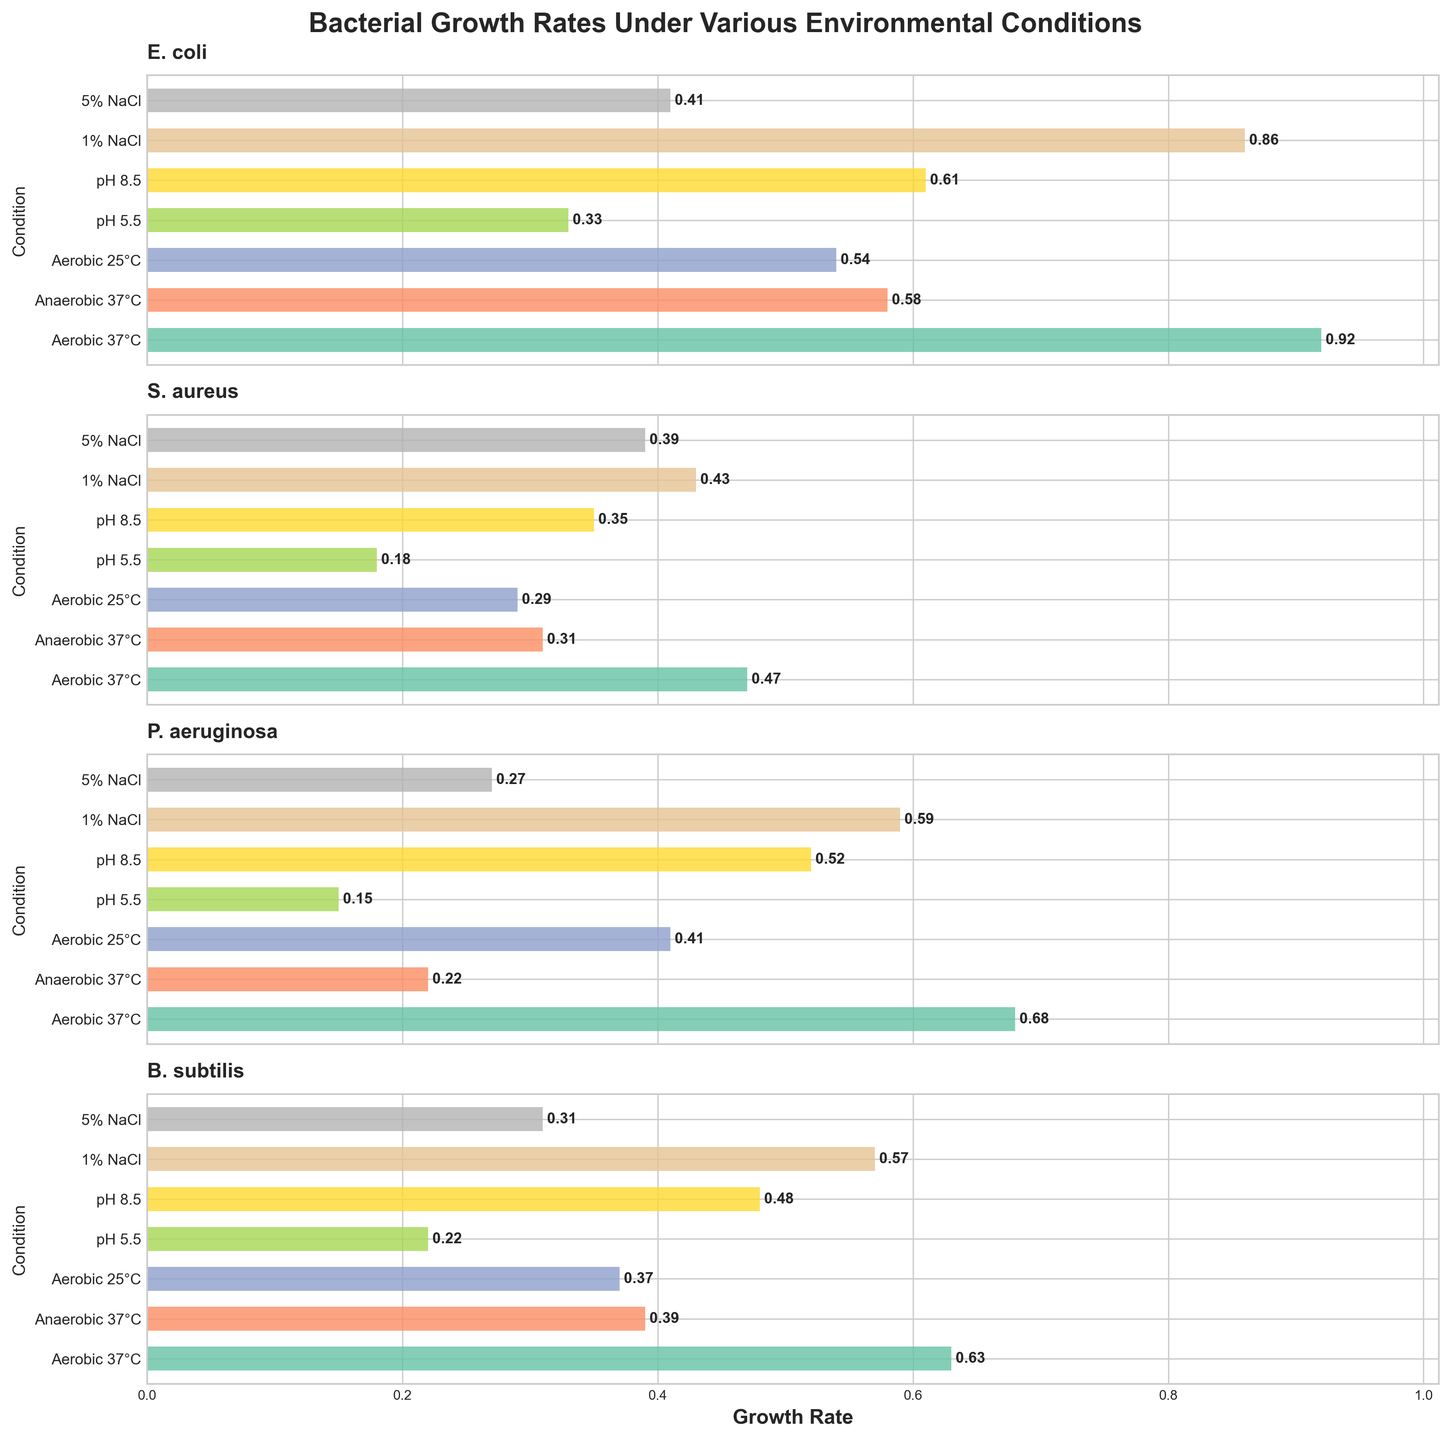What is the title of the figure? The title is usually located at the top of the figure and is meant to provide an overview of what the plot represents. Here, it states the focus on bacterial growth rates under different conditions.
Answer: Bacterial Growth Rates Under Various Environmental Conditions Which bacterium shows the highest growth rate under Aerobic 37°C conditions? To determine this, look at the bar heights for Aerobic 37°C condition across all subplots. Find the one with the highest value. E. coli shows the highest bar.
Answer: E. coli What is the difference in growth rate between E. coli and S. aureus under Anaerobic 37°C conditions? Locate the bars for E. coli and S. aureus under Anaerobic 37°C in their respective subplots. E. coli is 0.58 and S. aureus is 0.31. Subtract 0.31 from 0.58.
Answer: 0.27 Which condition has the highest average growth rate across all bacteria? Compute the average of growth rates for each condition across all bacteria. Compare these averages to find the highest. Aerobic 37°C has the highest average when you calculate the mean for each condition.
Answer: Aerobic 37°C How does the growth rate of P. aeruginosa under pH 8.5 compare to its growth rate under pH 5.5? Find P. aeruginosa's growth rates under both pH conditions. Under pH 8.5 it is 0.52 and under pH 5.5 it is 0.15. pH 8.5 is therefore higher.
Answer: Higher under pH 8.5 Which bacterium shows the least variation in growth rates across all conditions? For each bacterium, calculate the range (max - min) of growth rates across all conditions. S. aureus has the smallest range.
Answer: S. aureus What is the range of growth rates for B. subtilis across all conditions? Identify the maximum and minimum growth rates for B. subtilis from its subplot. Max is 0.63 (Aerobic 37°C) and min is 0.22 (pH 5.5). Subtract min from max.
Answer: 0.41 Under which conditions does S. aureus grow faster than P. aeruginosa? Compare the growth rates of S. aureus and P. aeruginosa under each condition. Look for the bars where S. aureus has a higher value. Conditions are 5% NaCl and Anaerobic 37°C.
Answer: 5% NaCl, Anaerobic 37°C What is the combined growth rate of E. coli and B. subtilis under 1% NaCl condition? Find E. coli’s and B. subtilis’s values under 1% NaCl, which are 0.86 and 0.57 respectively. Add these values together.
Answer: 1.43 